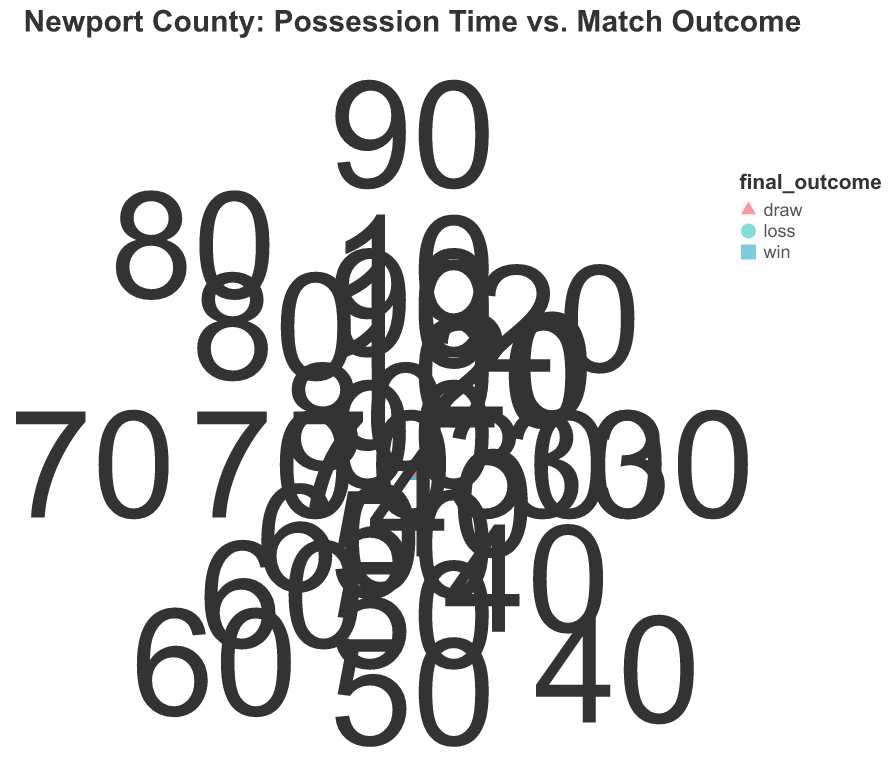How does the possession percentage trend differ between wins and losses over the intervals? To determine the trend, observe the radii of points for intervals. Winning outcomes (green circle points) generally show larger radii (higher possession percentage) over intervals compared to losing outcomes (red triangle points).
Answer: Higher possession percentage in wins What is the possession percentage for Newport County at the 30th minute in draws? Locate the shape corresponding to draws (square) at the 30-minute interval. The radius for draws here indicates the possession percentage.
Answer: 52% How many intervals show a possession percentage greater than 60%? Identify all points with radii corresponding to possession percentages above 60%. These are: 60 minutes (win), 70 minutes (win), 80 minutes (win), 90 minutes (win).
Answer: 4 intervals Is there any interval where the possession percentage for a loss is higher than 50%? Check all points marked as losses (red triangles) and identify any with a radius representing possession percentages above 50%. There is none.
Answer: No Which match outcome has the highest possession percentage at the 90th minute interval? Look at the points at the 90-minute interval and compare their radii. The win (green circle) has the highest radius.
Answer: Win Compare possession percentages at the 50th minute for different match outcomes. For the 50th minute, compare radii of the shapes: loss (44%), win (57%), draw (50%).
Answer: Win > Draw > Loss What pattern or trend do you observe for possession percentages over time for draws? Analyze the possession percentages (radii) for draw outcomes (squares): 10 minutes (50%), 20 minutes (48%), 30 minutes (52%), 40 minutes (51%), 50 minutes (50%), 60 minutes (53%), 70 minutes (49%), 80 minutes (54%), 90 minutes (51%). There's no clear increasing or decreasing trend overall.
Answer: No clear trend How does the possession percentage at the 10th minute differ across outcomes? Compare possession percentages for different outcomes at 10 minutes: win (54%), draw (50%), loss (45%).
Answer: Win > Draw > Loss Which interval shows the greatest difference in possession percentage between a win and a loss? Calculate differences in possession percentages for each interval and identify the largest: 10 minutes (54-45=9), 20 minutes (55-49=6), 30 minutes (60-47=13), 40 minutes (63-42=21), 50 minutes (57-44=13), 60 minutes (62-46=16), 70 minutes (66-41=25), 80 minutes (65-43=22), 90 minutes (67-40=27). The greatest difference is at 90 minutes.
Answer: 90 minutes What's the average possession percentage for wins? Sum possession percentages for wins and divide by number of win intervals: (54+55+60+63+57+62+66+65+67)/9 = 545/9 ≈ 60.56.
Answer: ~60.56% 